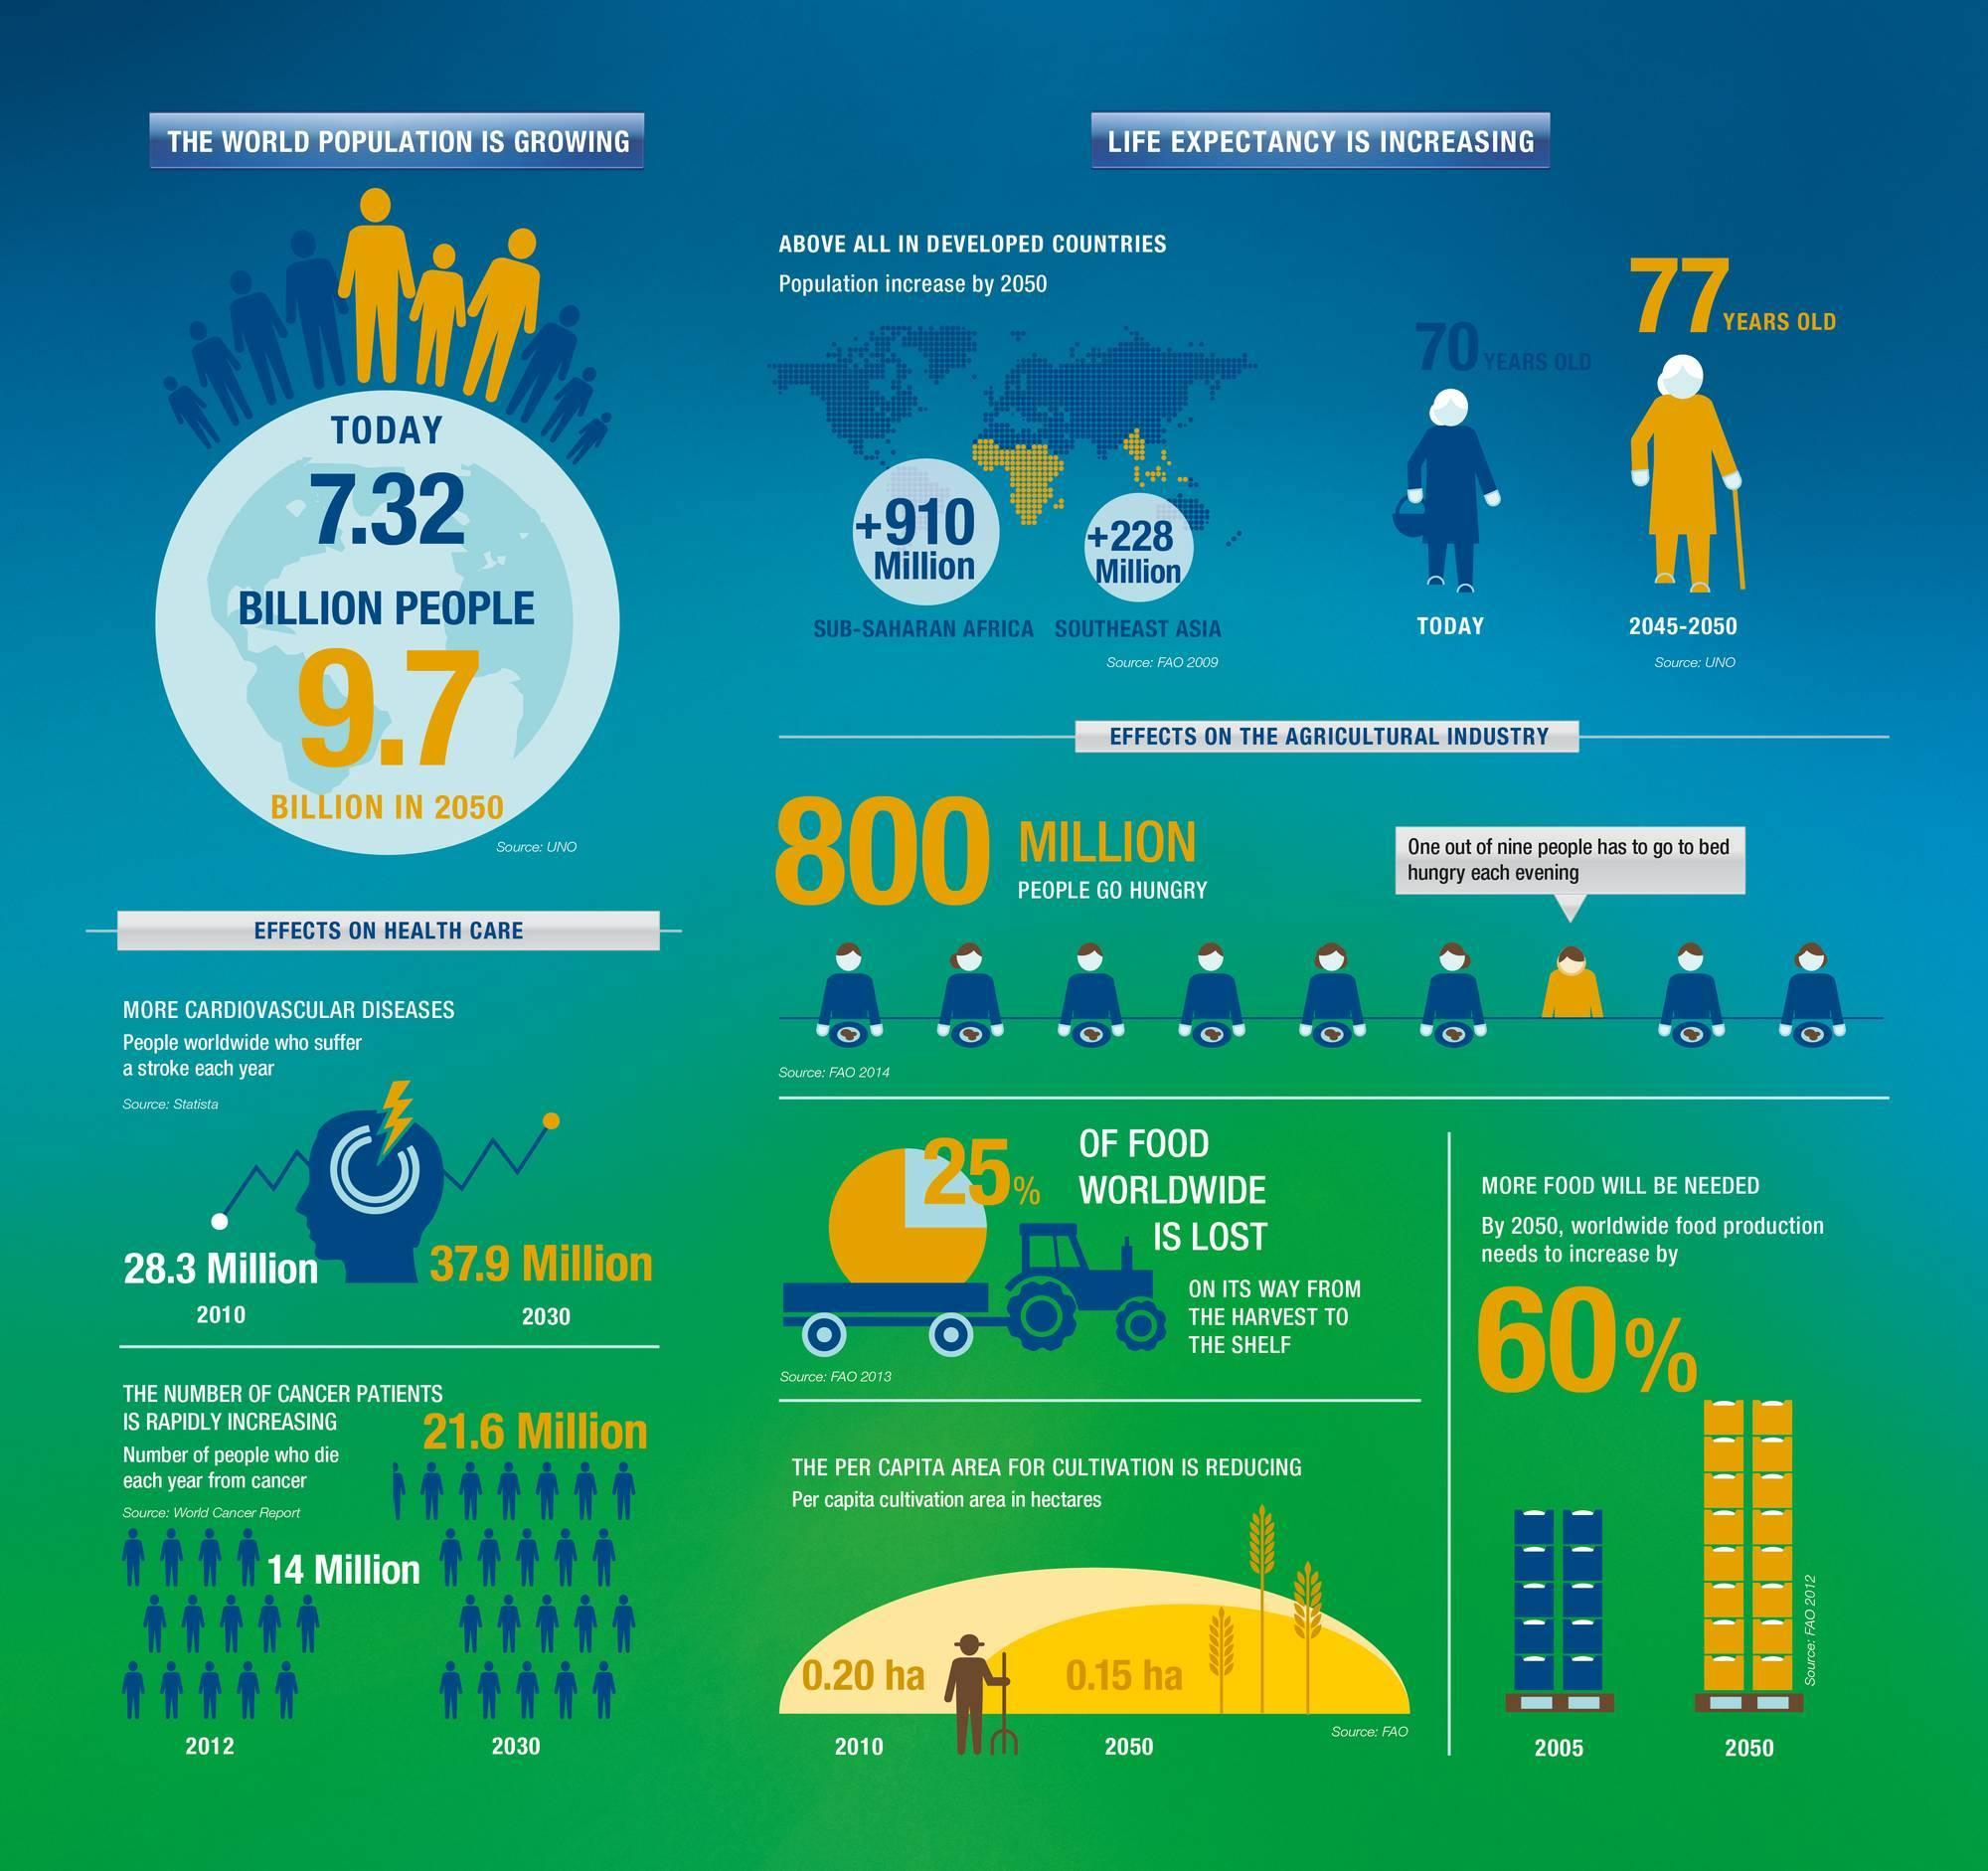Identify some key points in this picture. It is estimated that approximately 75% of food worldwide is able to reach consumers without being lost along the way from the harvest to the shelf. In 2030, there were approximately 7.6 million more cancer patients compared to 2012. Eight out of nine children go to bed without being hungry. The difference in life expectancy between 2045-2050 and today is projected to be seven years. 